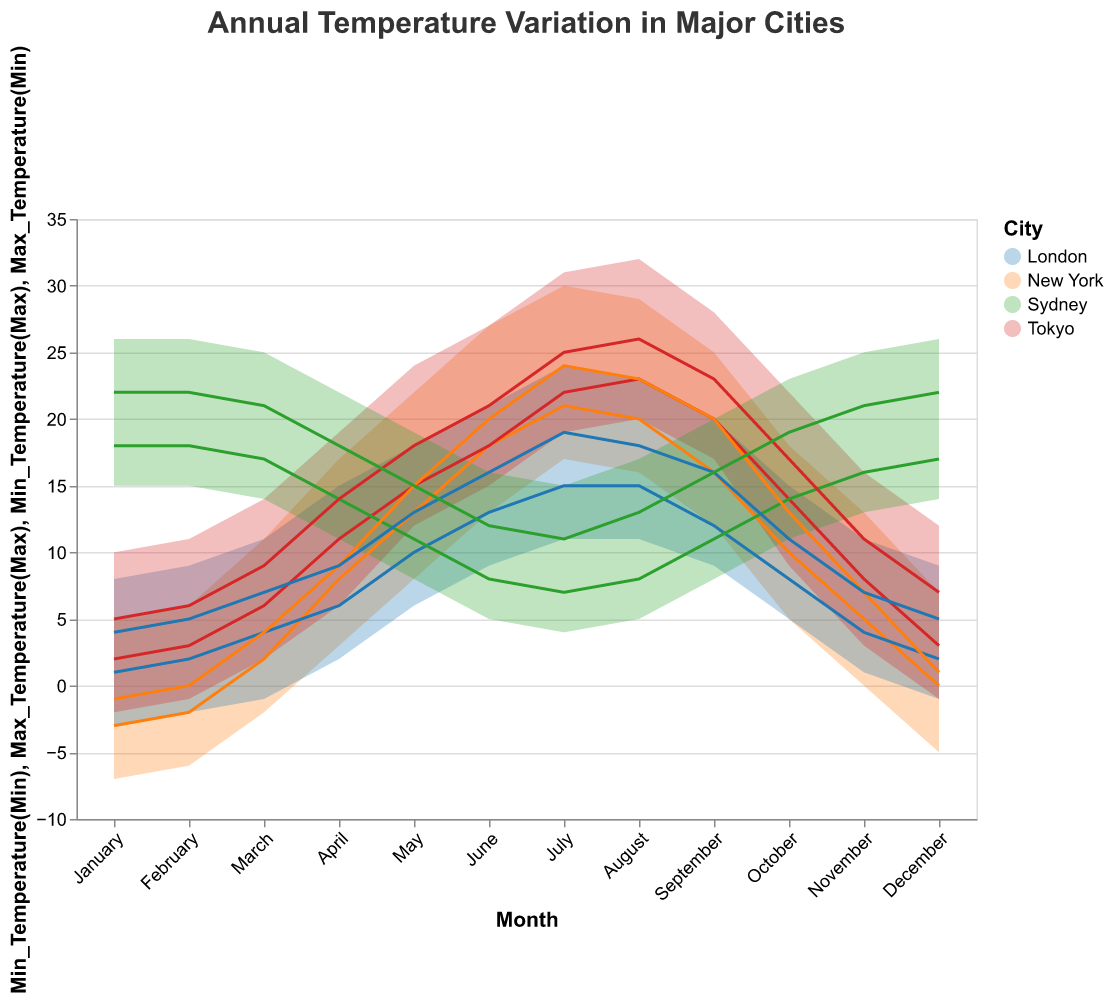What is the title of the chart? The title is displayed prominently at the top of the chart. It reads "Annual Temperature Variation in Major Cities."
Answer: Annual Temperature Variation in Major Cities What is the range of minimum temperatures (from Min) in New York in January? The chart shows a filled area representing the range from the Min_Temperature(Min) to the Max_Temperature(Min). For New York in January, the Min_Temperature(Min) is -7.0°C.
Answer: -7.0°C During which month does Sydney experience the highest maximum temperature? By looking at the highest point in the Max_Temperature(Max) line for Sydney, we can see that it occurs in January, February, and December, where the maximum temperature reaches 26.0°C.
Answer: January, February, December Compare the temperature variation range in July between Tokyo and New York. Which city experiences a wider range? In July, Tokyo's minimum and maximum temperatures range from 19.0°C to 31.0°C, making a variation of 12°C. New York's temperatures range from 17.0°C to 30.0°C, with a variation of 13°C. Thus, New York experiences a slightly wider range.
Answer: New York What is the minimum temperature range in London in October? In October, the minimum range for London is between the Min_Temperature(Min) and Min_Temperature(Max). The range is from 5.0°C to 8.0°C, giving a range of 3°C.
Answer: 3°C Which city has the highest minimum temperature in January? By examining the Min_Temperature(Max) line, Sydney has the highest minimum temperature in January at 18.0°C.
Answer: Sydney What is the average maximum temperature range in Tokyo across the months of June, July, and August? June's Max_Temperature(Max) to Max_Temperature(Min) is 27.0°C to 21.0°C. July's is 31.0°C to 25.0°C. August's is 32.0°C to 26.0°C. The ranges are 6°C, 6°C, and 6°C respectively. Adding and dividing by 3, the average is (6+6+6)/3 = 6°C.
Answer: 6°C During which month does London have the smallest temperature range for maximum temperatures? Reviewing the range area, London has the smallest maximum temperature range in November, going from 7.0°C to 11.0°C, which is a 4°C range.
Answer: November Between Tokyo and Sydney, which city shows a more significant temperature range difference in December? Tokyo's Max and Min temperatures in December range from 12.0°C to -1.0°C (13 degrees). Sydney’s range is from 26.0°C to 14.0°C (12 degrees). Therefore, Tokyo has a larger difference.
Answer: Tokyo 